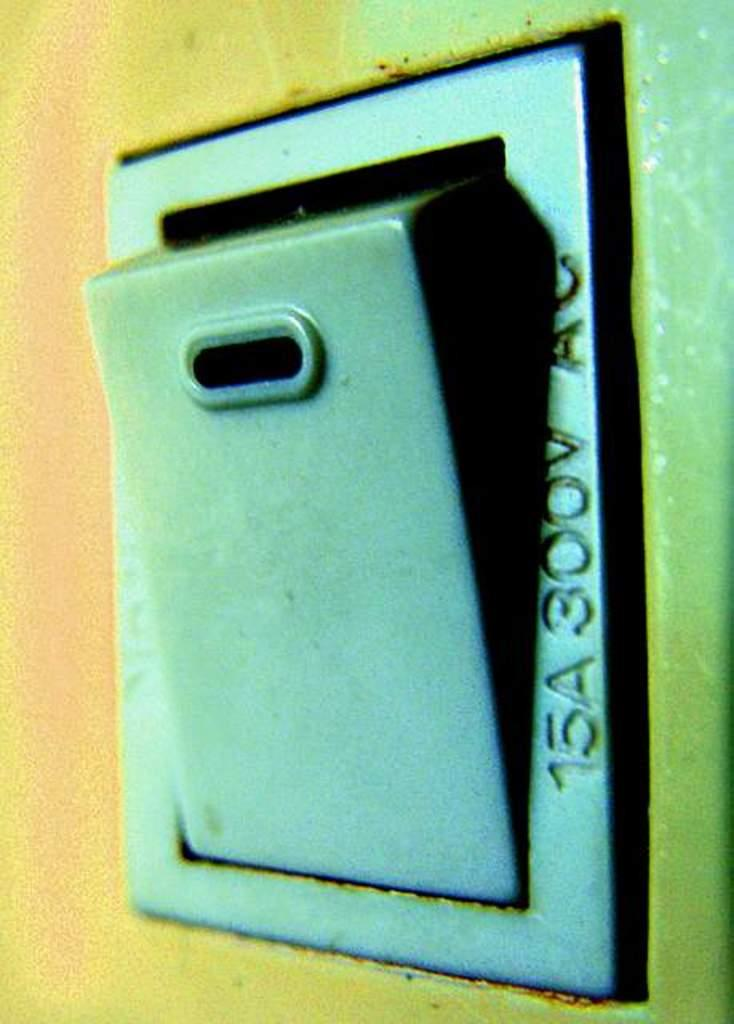<image>
Give a short and clear explanation of the subsequent image. The picture of the old mailbox says 15A300V Ac along the side. 